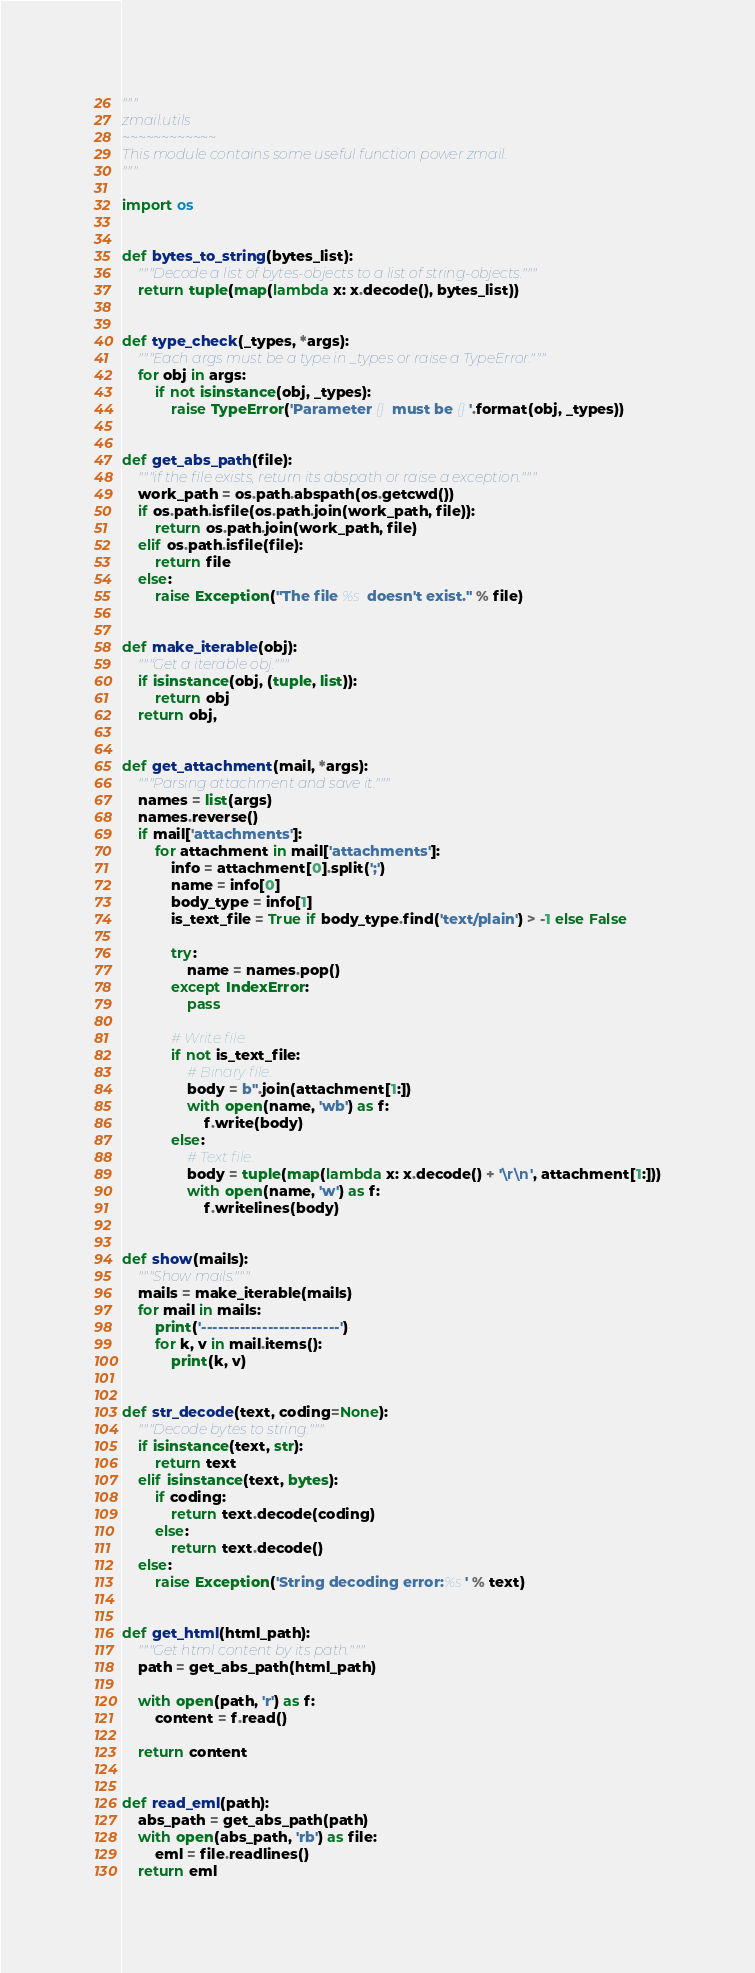Convert code to text. <code><loc_0><loc_0><loc_500><loc_500><_Python_>"""
zmail.utils
~~~~~~~~~~~~
This module contains some useful function power zmail.
"""

import os


def bytes_to_string(bytes_list):
    """Decode a list of bytes-objects to a list of string-objects."""
    return tuple(map(lambda x: x.decode(), bytes_list))


def type_check(_types, *args):
    """Each args must be a type in _types or raise a TypeError."""
    for obj in args:
        if not isinstance(obj, _types):
            raise TypeError('Parameter {} must be {}'.format(obj, _types))


def get_abs_path(file):
    """if the file exists, return its abspath or raise a exception."""
    work_path = os.path.abspath(os.getcwd())
    if os.path.isfile(os.path.join(work_path, file)):
        return os.path.join(work_path, file)
    elif os.path.isfile(file):
        return file
    else:
        raise Exception("The file %s doesn't exist." % file)


def make_iterable(obj):
    """Get a iterable obj."""
    if isinstance(obj, (tuple, list)):
        return obj
    return obj,


def get_attachment(mail, *args):
    """Parsing attachment and save it."""
    names = list(args)
    names.reverse()
    if mail['attachments']:
        for attachment in mail['attachments']:
            info = attachment[0].split(';')
            name = info[0]
            body_type = info[1]
            is_text_file = True if body_type.find('text/plain') > -1 else False

            try:
                name = names.pop()
            except IndexError:
                pass

            # Write file.
            if not is_text_file:
                # Binary file.
                body = b''.join(attachment[1:])
                with open(name, 'wb') as f:
                    f.write(body)
            else:
                # Text file.
                body = tuple(map(lambda x: x.decode() + '\r\n', attachment[1:]))
                with open(name, 'w') as f:
                    f.writelines(body)


def show(mails):
    """Show mails."""
    mails = make_iterable(mails)
    for mail in mails:
        print('-------------------------')
        for k, v in mail.items():
            print(k, v)


def str_decode(text, coding=None):
    """Decode bytes to string."""
    if isinstance(text, str):
        return text
    elif isinstance(text, bytes):
        if coding:
            return text.decode(coding)
        else:
            return text.decode()
    else:
        raise Exception('String decoding error:%s' % text)


def get_html(html_path):
    """Get html content by its path."""
    path = get_abs_path(html_path)

    with open(path, 'r') as f:
        content = f.read()

    return content


def read_eml(path):
    abs_path = get_abs_path(path)
    with open(abs_path, 'rb') as file:
        eml = file.readlines()
    return eml
</code> 